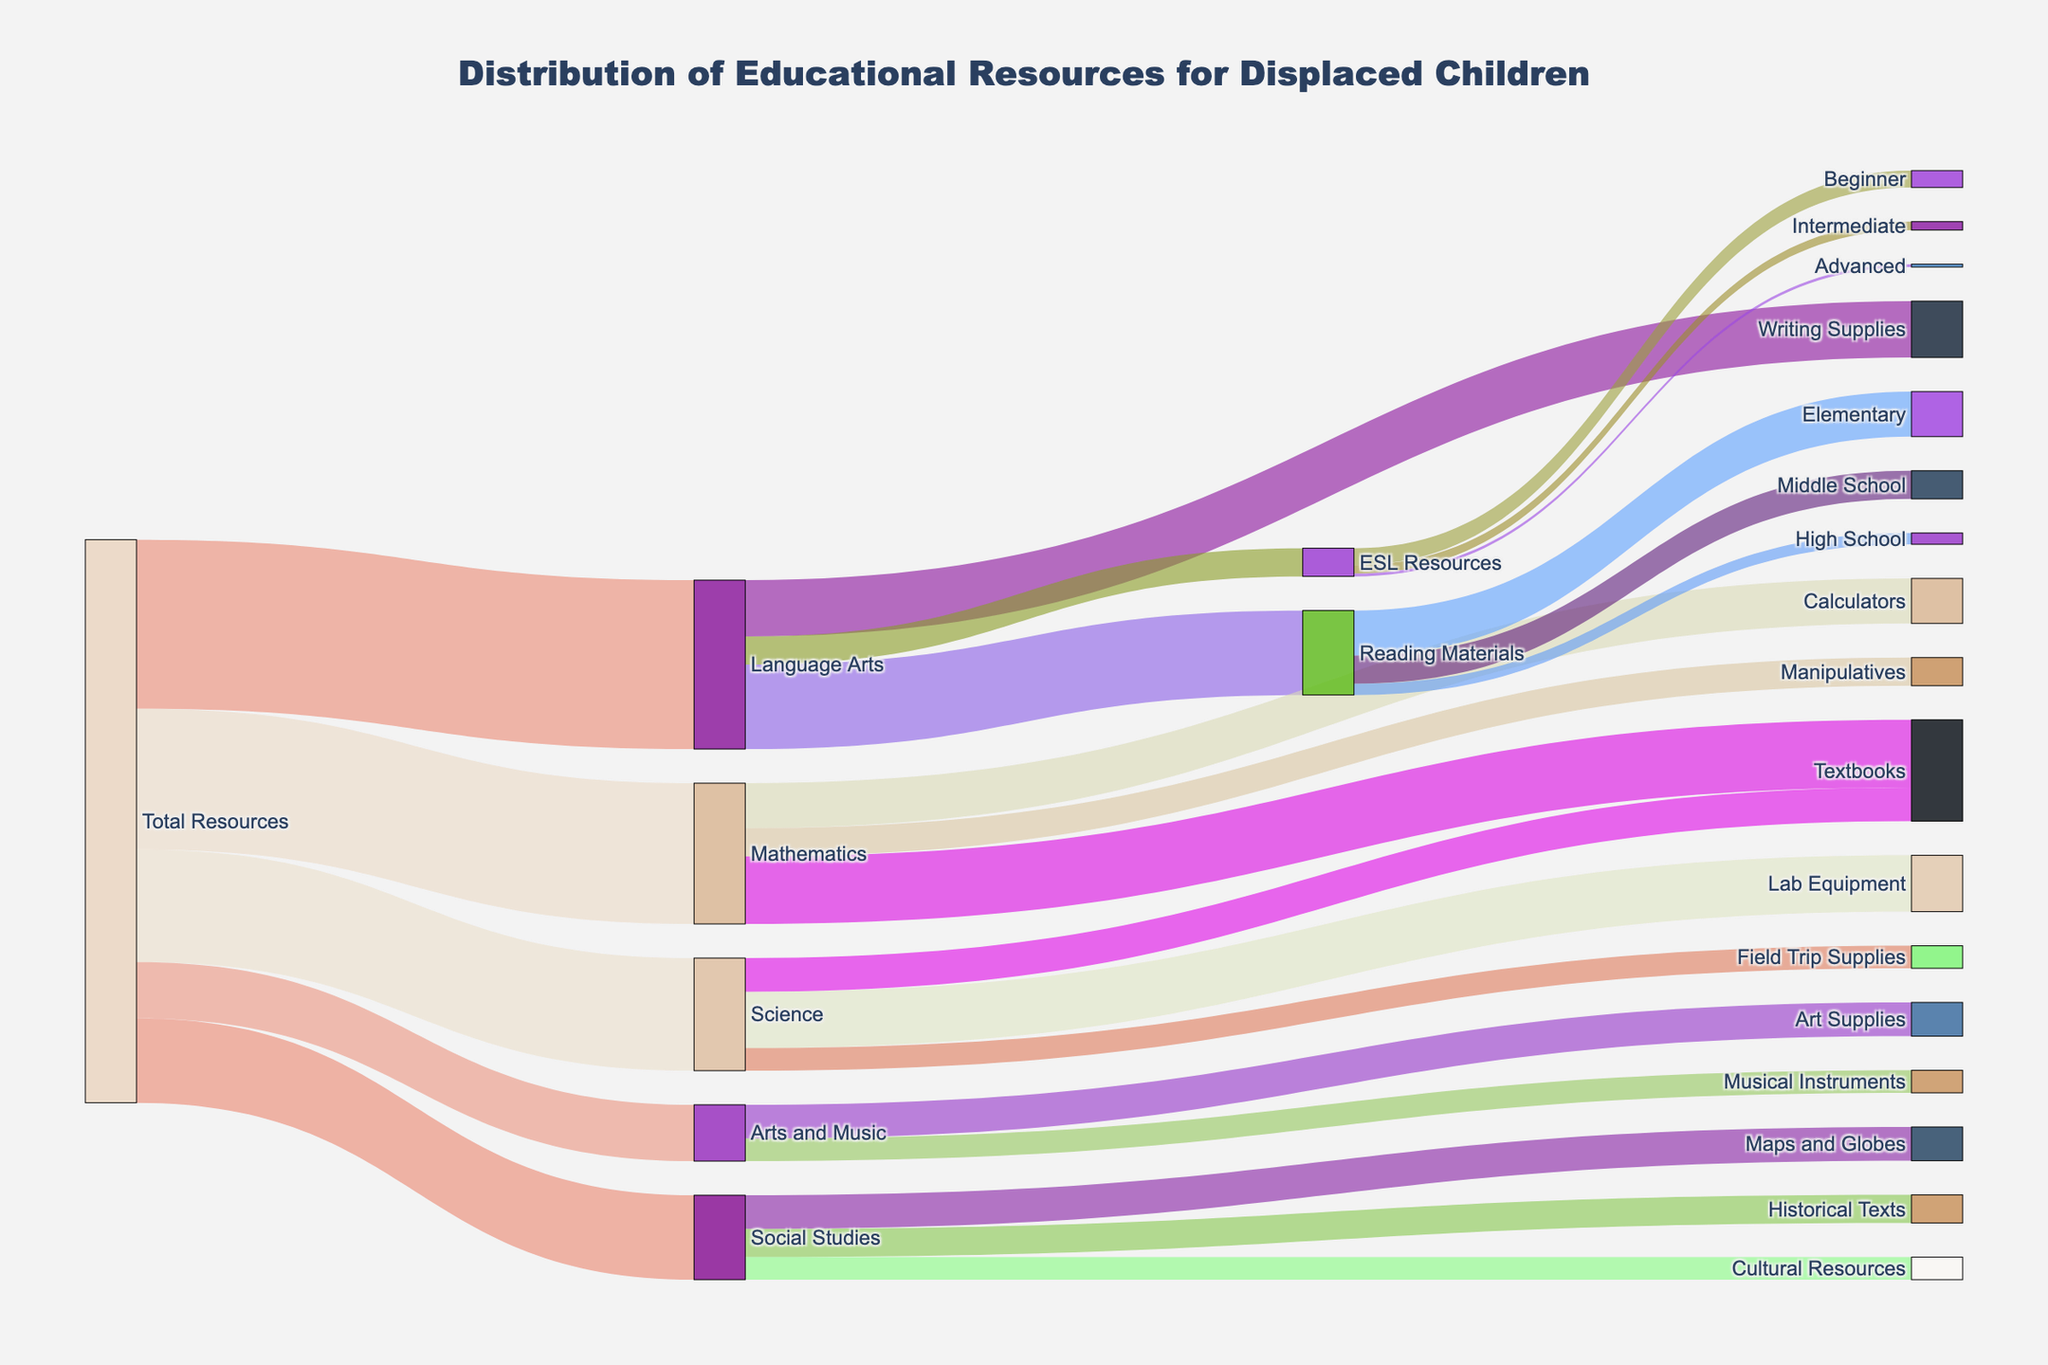what's the total number of resources allocated to Language Arts? To find the total number of resources allocated to Language Arts, look at the flow from "Total Resources" to "Language Arts," which shows a value of 3000.
Answer: 3000 Which subject receives the smallest amount of resources? By examining the flows from "Total Resources" to each subject, it is evident that "Arts and Music" receives the smallest amount of resources with a value of 1000.
Answer: Arts and Music How many resources are distributed for Mathematics textbooks? Look at the flow from "Mathematics" to "Textbooks," which shows a distribution of 1200 resources.
Answer: 1200 What's the total number of resources allocated to ESL Resources in Language Arts? First, look at the flow from "Language Arts" to "ESL Resources," which shows a value of 500.
Answer: 500 How are Reading Materials distributed across different education levels? Reading Materials have three sub-flows to different education levels: "Elementary" with 800 resources, "Middle School" with 500 resources, and "High School" with 200 resources. Summing these values gives the distribution across the levels.
Answer: Elementary: 800, Middle School: 500, High School: 200 How does the allocation of resources to Writing Supplies compare to Calculators? Writing Supplies receive 1000 resources while Calculators receive 800 resources. Writing Supplies have 200 more resources than Calculators.
Answer: Writing Supplies receive 200 more resources Are there more resources allocated to Lab Equipment or Field Trip Supplies in Science? The flow from "Science" to "Lab Equipment" shows 1000 resources, while "Field Trip Supplies" has 400 resources. Therefore, Lab Equipment receives more resources.
Answer: Lab Equipment How many resources are allocated to Historical Texts in Social Studies? Look at the flow from "Social Studies" to "Historical Texts," which shows a value of 500 resources.
Answer: 500 Which educational level receives the least resources within the Reading Materials category? In the Reading Materials category, look at the sub-flows: "Elementary" (800), "Middle School" (500), and "High School" (200). "High School" receives the least resources, which is 200.
Answer: High School How do the resource allocations to Art Supplies and Musical Instruments within Arts and Music compare? In the flows from "Arts and Music," Art Supplies receive 600 resources while Musical Instruments receive 400 resources. Thus, Art Supplies have 200 more resources than Musical Instruments.
Answer: Art Supplies receive 200 more resources 